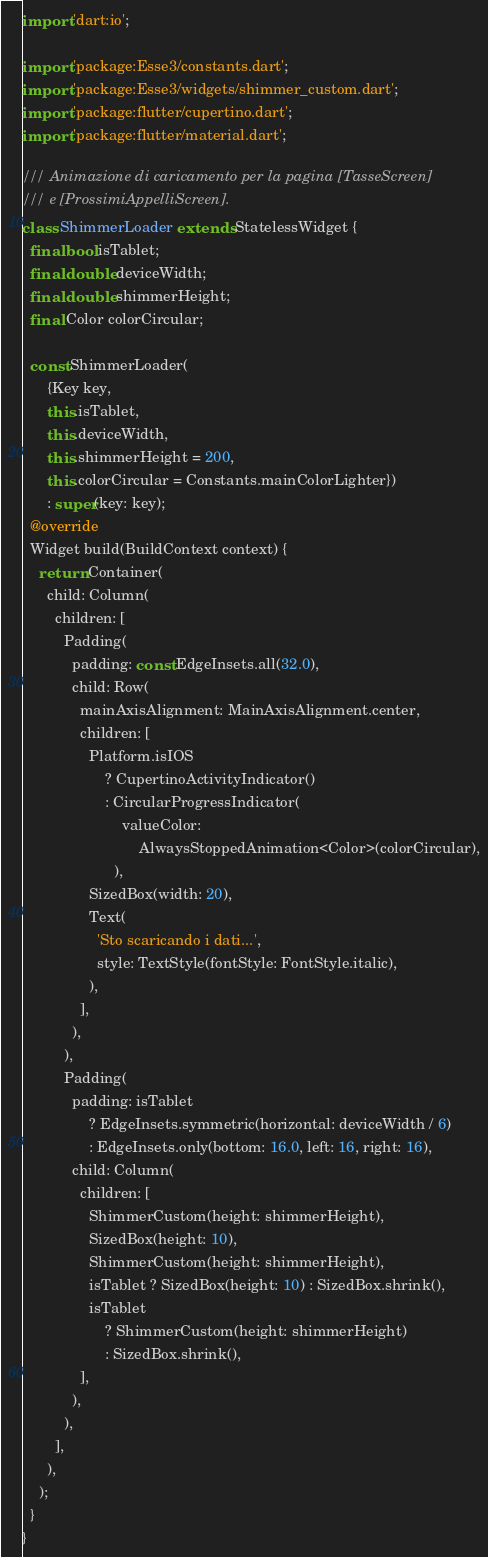Convert code to text. <code><loc_0><loc_0><loc_500><loc_500><_Dart_>import 'dart:io';

import 'package:Esse3/constants.dart';
import 'package:Esse3/widgets/shimmer_custom.dart';
import 'package:flutter/cupertino.dart';
import 'package:flutter/material.dart';

/// Animazione di caricamento per la pagina [TasseScreen]
/// e [ProssimiAppelliScreen].
class ShimmerLoader extends StatelessWidget {
  final bool isTablet;
  final double deviceWidth;
  final double shimmerHeight;
  final Color colorCircular;

  const ShimmerLoader(
      {Key key,
      this.isTablet,
      this.deviceWidth,
      this.shimmerHeight = 200,
      this.colorCircular = Constants.mainColorLighter})
      : super(key: key);
  @override
  Widget build(BuildContext context) {
    return Container(
      child: Column(
        children: [
          Padding(
            padding: const EdgeInsets.all(32.0),
            child: Row(
              mainAxisAlignment: MainAxisAlignment.center,
              children: [
                Platform.isIOS
                    ? CupertinoActivityIndicator()
                    : CircularProgressIndicator(
                        valueColor:
                            AlwaysStoppedAnimation<Color>(colorCircular),
                      ),
                SizedBox(width: 20),
                Text(
                  'Sto scaricando i dati...',
                  style: TextStyle(fontStyle: FontStyle.italic),
                ),
              ],
            ),
          ),
          Padding(
            padding: isTablet
                ? EdgeInsets.symmetric(horizontal: deviceWidth / 6)
                : EdgeInsets.only(bottom: 16.0, left: 16, right: 16),
            child: Column(
              children: [
                ShimmerCustom(height: shimmerHeight),
                SizedBox(height: 10),
                ShimmerCustom(height: shimmerHeight),
                isTablet ? SizedBox(height: 10) : SizedBox.shrink(),
                isTablet
                    ? ShimmerCustom(height: shimmerHeight)
                    : SizedBox.shrink(),
              ],
            ),
          ),
        ],
      ),
    );
  }
}
</code> 